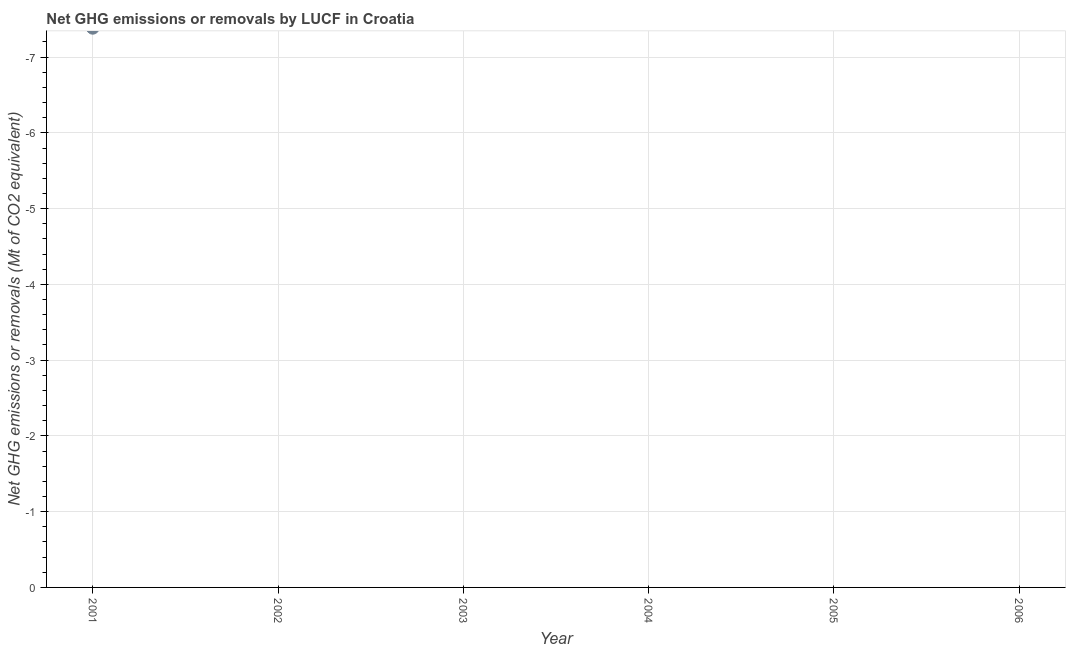What is the sum of the ghg net emissions or removals?
Your response must be concise. 0. What is the average ghg net emissions or removals per year?
Ensure brevity in your answer.  0. Does the ghg net emissions or removals monotonically increase over the years?
Offer a terse response. No. Does the graph contain any zero values?
Provide a short and direct response. Yes. Does the graph contain grids?
Offer a very short reply. Yes. What is the title of the graph?
Keep it short and to the point. Net GHG emissions or removals by LUCF in Croatia. What is the label or title of the Y-axis?
Offer a very short reply. Net GHG emissions or removals (Mt of CO2 equivalent). What is the Net GHG emissions or removals (Mt of CO2 equivalent) in 2001?
Give a very brief answer. 0. What is the Net GHG emissions or removals (Mt of CO2 equivalent) in 2006?
Your answer should be very brief. 0. 